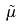<formula> <loc_0><loc_0><loc_500><loc_500>\tilde { \mu }</formula> 